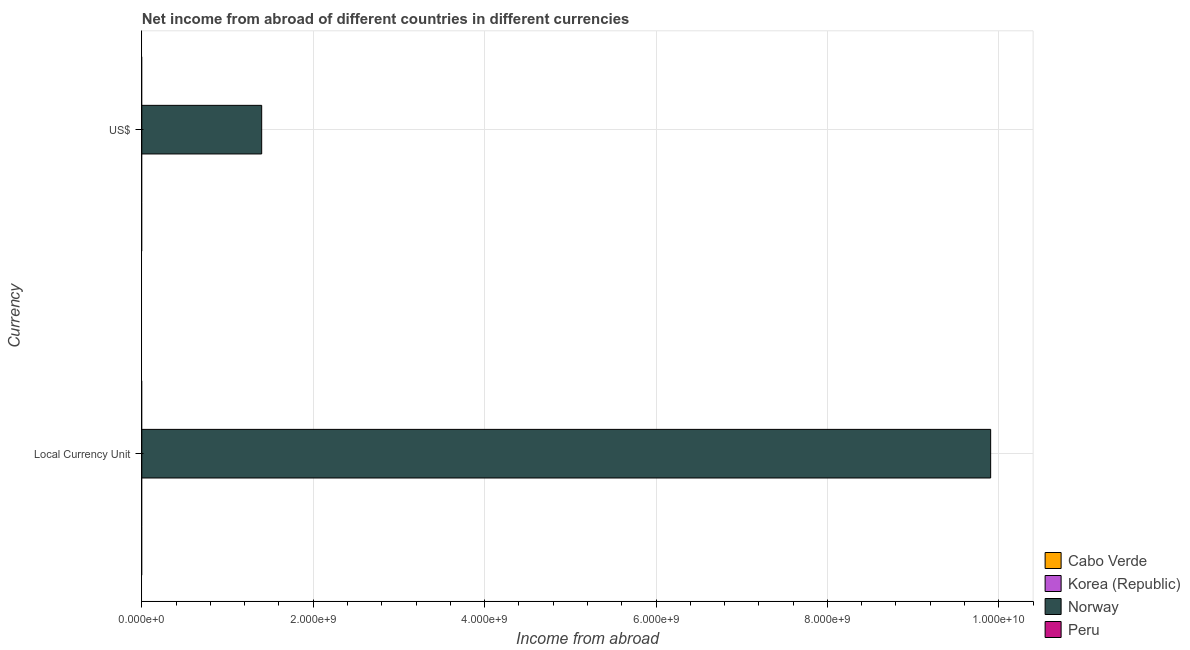How many different coloured bars are there?
Offer a very short reply. 1. Are the number of bars per tick equal to the number of legend labels?
Offer a terse response. No. What is the label of the 2nd group of bars from the top?
Offer a very short reply. Local Currency Unit. Across all countries, what is the maximum income from abroad in us$?
Ensure brevity in your answer.  1.40e+09. Across all countries, what is the minimum income from abroad in us$?
Ensure brevity in your answer.  0. In which country was the income from abroad in constant 2005 us$ maximum?
Offer a very short reply. Norway. What is the total income from abroad in constant 2005 us$ in the graph?
Your response must be concise. 9.90e+09. What is the difference between the income from abroad in us$ in Cabo Verde and the income from abroad in constant 2005 us$ in Norway?
Your answer should be compact. -9.90e+09. What is the average income from abroad in us$ per country?
Provide a short and direct response. 3.50e+08. What is the difference between the income from abroad in constant 2005 us$ and income from abroad in us$ in Norway?
Provide a short and direct response. 8.51e+09. In how many countries, is the income from abroad in constant 2005 us$ greater than 6000000000 units?
Offer a very short reply. 1. In how many countries, is the income from abroad in constant 2005 us$ greater than the average income from abroad in constant 2005 us$ taken over all countries?
Your response must be concise. 1. How many bars are there?
Your answer should be very brief. 2. Are all the bars in the graph horizontal?
Your answer should be compact. Yes. How many countries are there in the graph?
Provide a succinct answer. 4. What is the difference between two consecutive major ticks on the X-axis?
Your response must be concise. 2.00e+09. Does the graph contain any zero values?
Your answer should be compact. Yes. Where does the legend appear in the graph?
Make the answer very short. Bottom right. How many legend labels are there?
Offer a terse response. 4. How are the legend labels stacked?
Offer a very short reply. Vertical. What is the title of the graph?
Provide a short and direct response. Net income from abroad of different countries in different currencies. What is the label or title of the X-axis?
Provide a short and direct response. Income from abroad. What is the label or title of the Y-axis?
Offer a terse response. Currency. What is the Income from abroad in Norway in Local Currency Unit?
Offer a very short reply. 9.90e+09. What is the Income from abroad of Peru in Local Currency Unit?
Offer a terse response. 0. What is the Income from abroad in Cabo Verde in US$?
Give a very brief answer. 0. What is the Income from abroad of Korea (Republic) in US$?
Provide a short and direct response. 0. What is the Income from abroad in Norway in US$?
Keep it short and to the point. 1.40e+09. What is the Income from abroad of Peru in US$?
Offer a terse response. 0. Across all Currency, what is the maximum Income from abroad of Norway?
Keep it short and to the point. 9.90e+09. Across all Currency, what is the minimum Income from abroad of Norway?
Your response must be concise. 1.40e+09. What is the total Income from abroad in Cabo Verde in the graph?
Provide a short and direct response. 0. What is the total Income from abroad of Korea (Republic) in the graph?
Provide a succinct answer. 0. What is the total Income from abroad in Norway in the graph?
Your response must be concise. 1.13e+1. What is the total Income from abroad in Peru in the graph?
Your response must be concise. 0. What is the difference between the Income from abroad in Norway in Local Currency Unit and that in US$?
Your answer should be compact. 8.51e+09. What is the average Income from abroad of Cabo Verde per Currency?
Give a very brief answer. 0. What is the average Income from abroad of Norway per Currency?
Ensure brevity in your answer.  5.65e+09. What is the average Income from abroad of Peru per Currency?
Provide a succinct answer. 0. What is the ratio of the Income from abroad in Norway in Local Currency Unit to that in US$?
Your answer should be very brief. 7.08. What is the difference between the highest and the second highest Income from abroad in Norway?
Give a very brief answer. 8.51e+09. What is the difference between the highest and the lowest Income from abroad in Norway?
Your answer should be very brief. 8.51e+09. 